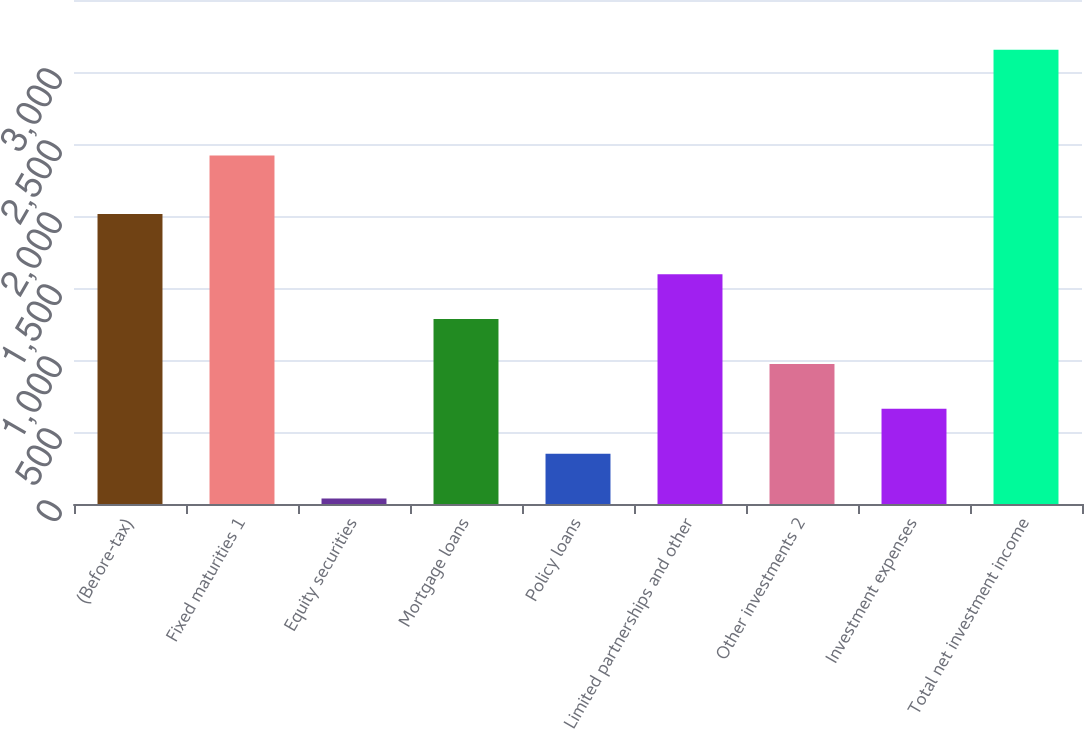<chart> <loc_0><loc_0><loc_500><loc_500><bar_chart><fcel>(Before-tax)<fcel>Fixed maturities 1<fcel>Equity securities<fcel>Mortgage loans<fcel>Policy loans<fcel>Limited partnerships and other<fcel>Other investments 2<fcel>Investment expenses<fcel>Total net investment income<nl><fcel>2014<fcel>2420<fcel>38<fcel>1284.4<fcel>349.6<fcel>1596<fcel>972.8<fcel>661.2<fcel>3154<nl></chart> 